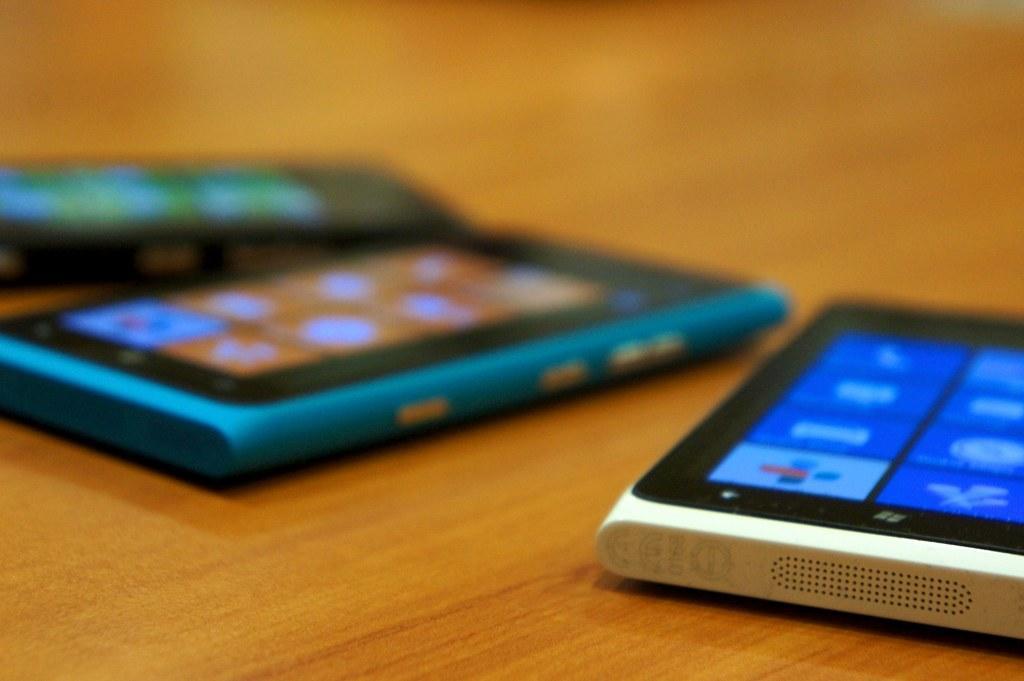How would you summarize this image in a sentence or two? In this image we can see mobiles. The background of the image is blur. 